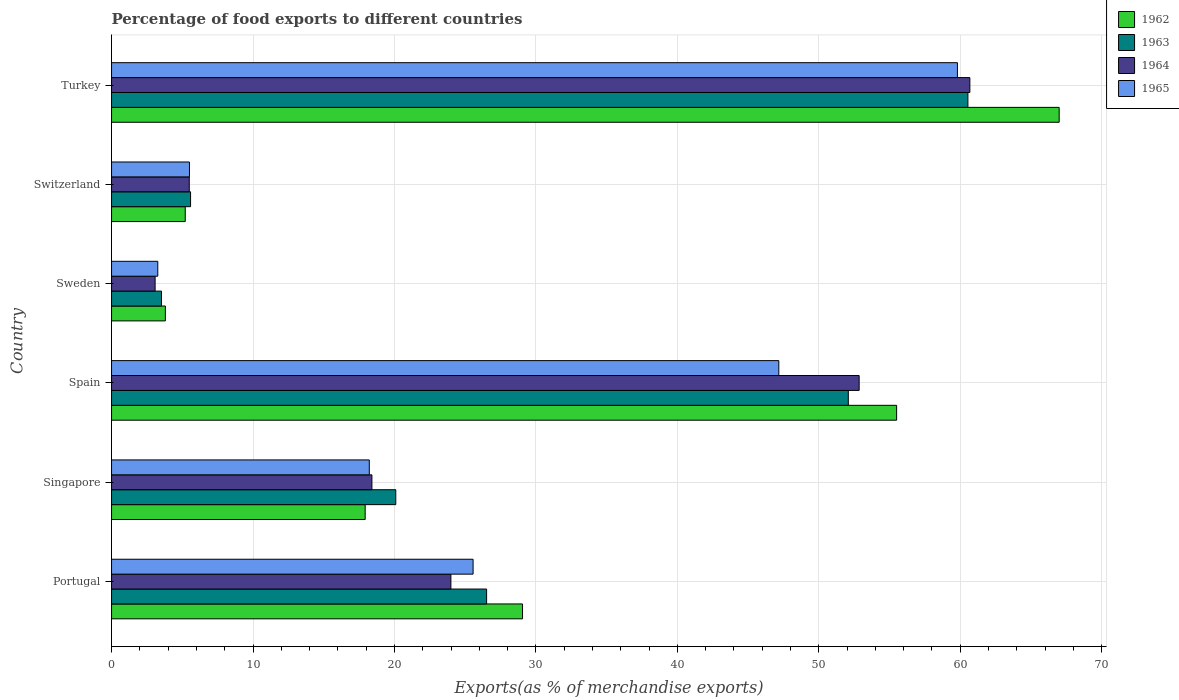How many different coloured bars are there?
Ensure brevity in your answer.  4. Are the number of bars per tick equal to the number of legend labels?
Offer a terse response. Yes. What is the label of the 3rd group of bars from the top?
Offer a terse response. Sweden. What is the percentage of exports to different countries in 1965 in Switzerland?
Provide a short and direct response. 5.51. Across all countries, what is the maximum percentage of exports to different countries in 1963?
Your response must be concise. 60.54. Across all countries, what is the minimum percentage of exports to different countries in 1964?
Make the answer very short. 3.08. In which country was the percentage of exports to different countries in 1965 maximum?
Your answer should be compact. Turkey. What is the total percentage of exports to different countries in 1963 in the graph?
Provide a short and direct response. 168.35. What is the difference between the percentage of exports to different countries in 1964 in Sweden and that in Switzerland?
Your answer should be compact. -2.41. What is the difference between the percentage of exports to different countries in 1963 in Portugal and the percentage of exports to different countries in 1965 in Singapore?
Your answer should be very brief. 8.29. What is the average percentage of exports to different countries in 1963 per country?
Ensure brevity in your answer.  28.06. What is the difference between the percentage of exports to different countries in 1962 and percentage of exports to different countries in 1965 in Singapore?
Ensure brevity in your answer.  -0.29. What is the ratio of the percentage of exports to different countries in 1962 in Portugal to that in Singapore?
Give a very brief answer. 1.62. Is the percentage of exports to different countries in 1963 in Portugal less than that in Switzerland?
Provide a succinct answer. No. What is the difference between the highest and the second highest percentage of exports to different countries in 1964?
Offer a terse response. 7.83. What is the difference between the highest and the lowest percentage of exports to different countries in 1965?
Your answer should be very brief. 56.53. What does the 1st bar from the top in Sweden represents?
Offer a very short reply. 1965. What does the 3rd bar from the bottom in Portugal represents?
Ensure brevity in your answer.  1964. How many bars are there?
Your response must be concise. 24. What is the difference between two consecutive major ticks on the X-axis?
Provide a succinct answer. 10. Are the values on the major ticks of X-axis written in scientific E-notation?
Your answer should be very brief. No. Does the graph contain grids?
Keep it short and to the point. Yes. Where does the legend appear in the graph?
Your answer should be compact. Top right. How many legend labels are there?
Offer a very short reply. 4. How are the legend labels stacked?
Your response must be concise. Vertical. What is the title of the graph?
Offer a very short reply. Percentage of food exports to different countries. What is the label or title of the X-axis?
Provide a short and direct response. Exports(as % of merchandise exports). What is the label or title of the Y-axis?
Your answer should be very brief. Country. What is the Exports(as % of merchandise exports) of 1962 in Portugal?
Make the answer very short. 29.05. What is the Exports(as % of merchandise exports) in 1963 in Portugal?
Keep it short and to the point. 26.51. What is the Exports(as % of merchandise exports) of 1964 in Portugal?
Make the answer very short. 23.99. What is the Exports(as % of merchandise exports) in 1965 in Portugal?
Give a very brief answer. 25.56. What is the Exports(as % of merchandise exports) of 1962 in Singapore?
Provide a succinct answer. 17.93. What is the Exports(as % of merchandise exports) of 1963 in Singapore?
Give a very brief answer. 20.09. What is the Exports(as % of merchandise exports) in 1964 in Singapore?
Keep it short and to the point. 18.41. What is the Exports(as % of merchandise exports) in 1965 in Singapore?
Ensure brevity in your answer.  18.22. What is the Exports(as % of merchandise exports) in 1962 in Spain?
Your answer should be very brief. 55.5. What is the Exports(as % of merchandise exports) in 1963 in Spain?
Your answer should be compact. 52.09. What is the Exports(as % of merchandise exports) of 1964 in Spain?
Ensure brevity in your answer.  52.85. What is the Exports(as % of merchandise exports) of 1965 in Spain?
Ensure brevity in your answer.  47.17. What is the Exports(as % of merchandise exports) of 1962 in Sweden?
Keep it short and to the point. 3.8. What is the Exports(as % of merchandise exports) of 1963 in Sweden?
Keep it short and to the point. 3.53. What is the Exports(as % of merchandise exports) in 1964 in Sweden?
Offer a very short reply. 3.08. What is the Exports(as % of merchandise exports) of 1965 in Sweden?
Your answer should be very brief. 3.27. What is the Exports(as % of merchandise exports) in 1962 in Switzerland?
Provide a succinct answer. 5.21. What is the Exports(as % of merchandise exports) of 1963 in Switzerland?
Provide a succinct answer. 5.59. What is the Exports(as % of merchandise exports) in 1964 in Switzerland?
Your answer should be compact. 5.49. What is the Exports(as % of merchandise exports) of 1965 in Switzerland?
Provide a succinct answer. 5.51. What is the Exports(as % of merchandise exports) of 1962 in Turkey?
Offer a terse response. 66.99. What is the Exports(as % of merchandise exports) in 1963 in Turkey?
Your response must be concise. 60.54. What is the Exports(as % of merchandise exports) in 1964 in Turkey?
Offer a terse response. 60.68. What is the Exports(as % of merchandise exports) in 1965 in Turkey?
Your answer should be very brief. 59.8. Across all countries, what is the maximum Exports(as % of merchandise exports) of 1962?
Keep it short and to the point. 66.99. Across all countries, what is the maximum Exports(as % of merchandise exports) in 1963?
Keep it short and to the point. 60.54. Across all countries, what is the maximum Exports(as % of merchandise exports) of 1964?
Offer a terse response. 60.68. Across all countries, what is the maximum Exports(as % of merchandise exports) in 1965?
Give a very brief answer. 59.8. Across all countries, what is the minimum Exports(as % of merchandise exports) of 1962?
Keep it short and to the point. 3.8. Across all countries, what is the minimum Exports(as % of merchandise exports) in 1963?
Keep it short and to the point. 3.53. Across all countries, what is the minimum Exports(as % of merchandise exports) of 1964?
Keep it short and to the point. 3.08. Across all countries, what is the minimum Exports(as % of merchandise exports) in 1965?
Ensure brevity in your answer.  3.27. What is the total Exports(as % of merchandise exports) of 1962 in the graph?
Offer a terse response. 178.49. What is the total Exports(as % of merchandise exports) of 1963 in the graph?
Offer a terse response. 168.35. What is the total Exports(as % of merchandise exports) in 1964 in the graph?
Give a very brief answer. 164.5. What is the total Exports(as % of merchandise exports) of 1965 in the graph?
Your response must be concise. 159.53. What is the difference between the Exports(as % of merchandise exports) of 1962 in Portugal and that in Singapore?
Offer a very short reply. 11.12. What is the difference between the Exports(as % of merchandise exports) in 1963 in Portugal and that in Singapore?
Your answer should be compact. 6.42. What is the difference between the Exports(as % of merchandise exports) in 1964 in Portugal and that in Singapore?
Your response must be concise. 5.58. What is the difference between the Exports(as % of merchandise exports) of 1965 in Portugal and that in Singapore?
Keep it short and to the point. 7.34. What is the difference between the Exports(as % of merchandise exports) of 1962 in Portugal and that in Spain?
Offer a very short reply. -26.45. What is the difference between the Exports(as % of merchandise exports) in 1963 in Portugal and that in Spain?
Offer a terse response. -25.57. What is the difference between the Exports(as % of merchandise exports) in 1964 in Portugal and that in Spain?
Offer a very short reply. -28.86. What is the difference between the Exports(as % of merchandise exports) in 1965 in Portugal and that in Spain?
Offer a very short reply. -21.61. What is the difference between the Exports(as % of merchandise exports) of 1962 in Portugal and that in Sweden?
Provide a succinct answer. 25.25. What is the difference between the Exports(as % of merchandise exports) of 1963 in Portugal and that in Sweden?
Give a very brief answer. 22.98. What is the difference between the Exports(as % of merchandise exports) of 1964 in Portugal and that in Sweden?
Provide a short and direct response. 20.91. What is the difference between the Exports(as % of merchandise exports) of 1965 in Portugal and that in Sweden?
Your answer should be compact. 22.29. What is the difference between the Exports(as % of merchandise exports) of 1962 in Portugal and that in Switzerland?
Your answer should be compact. 23.85. What is the difference between the Exports(as % of merchandise exports) in 1963 in Portugal and that in Switzerland?
Keep it short and to the point. 20.93. What is the difference between the Exports(as % of merchandise exports) in 1964 in Portugal and that in Switzerland?
Keep it short and to the point. 18.5. What is the difference between the Exports(as % of merchandise exports) of 1965 in Portugal and that in Switzerland?
Your answer should be very brief. 20.05. What is the difference between the Exports(as % of merchandise exports) in 1962 in Portugal and that in Turkey?
Provide a succinct answer. -37.94. What is the difference between the Exports(as % of merchandise exports) in 1963 in Portugal and that in Turkey?
Your response must be concise. -34.03. What is the difference between the Exports(as % of merchandise exports) in 1964 in Portugal and that in Turkey?
Offer a terse response. -36.69. What is the difference between the Exports(as % of merchandise exports) in 1965 in Portugal and that in Turkey?
Your answer should be compact. -34.24. What is the difference between the Exports(as % of merchandise exports) in 1962 in Singapore and that in Spain?
Provide a short and direct response. -37.57. What is the difference between the Exports(as % of merchandise exports) of 1963 in Singapore and that in Spain?
Provide a succinct answer. -31.99. What is the difference between the Exports(as % of merchandise exports) of 1964 in Singapore and that in Spain?
Your response must be concise. -34.45. What is the difference between the Exports(as % of merchandise exports) of 1965 in Singapore and that in Spain?
Provide a succinct answer. -28.95. What is the difference between the Exports(as % of merchandise exports) in 1962 in Singapore and that in Sweden?
Your answer should be compact. 14.13. What is the difference between the Exports(as % of merchandise exports) of 1963 in Singapore and that in Sweden?
Give a very brief answer. 16.56. What is the difference between the Exports(as % of merchandise exports) of 1964 in Singapore and that in Sweden?
Offer a terse response. 15.33. What is the difference between the Exports(as % of merchandise exports) of 1965 in Singapore and that in Sweden?
Keep it short and to the point. 14.95. What is the difference between the Exports(as % of merchandise exports) in 1962 in Singapore and that in Switzerland?
Your response must be concise. 12.72. What is the difference between the Exports(as % of merchandise exports) of 1963 in Singapore and that in Switzerland?
Offer a terse response. 14.51. What is the difference between the Exports(as % of merchandise exports) in 1964 in Singapore and that in Switzerland?
Your answer should be compact. 12.91. What is the difference between the Exports(as % of merchandise exports) of 1965 in Singapore and that in Switzerland?
Your response must be concise. 12.71. What is the difference between the Exports(as % of merchandise exports) of 1962 in Singapore and that in Turkey?
Ensure brevity in your answer.  -49.06. What is the difference between the Exports(as % of merchandise exports) in 1963 in Singapore and that in Turkey?
Your response must be concise. -40.45. What is the difference between the Exports(as % of merchandise exports) in 1964 in Singapore and that in Turkey?
Your answer should be very brief. -42.27. What is the difference between the Exports(as % of merchandise exports) in 1965 in Singapore and that in Turkey?
Provide a succinct answer. -41.58. What is the difference between the Exports(as % of merchandise exports) in 1962 in Spain and that in Sweden?
Give a very brief answer. 51.7. What is the difference between the Exports(as % of merchandise exports) in 1963 in Spain and that in Sweden?
Your answer should be compact. 48.56. What is the difference between the Exports(as % of merchandise exports) in 1964 in Spain and that in Sweden?
Give a very brief answer. 49.77. What is the difference between the Exports(as % of merchandise exports) in 1965 in Spain and that in Sweden?
Provide a short and direct response. 43.9. What is the difference between the Exports(as % of merchandise exports) of 1962 in Spain and that in Switzerland?
Your response must be concise. 50.29. What is the difference between the Exports(as % of merchandise exports) of 1963 in Spain and that in Switzerland?
Offer a very short reply. 46.5. What is the difference between the Exports(as % of merchandise exports) in 1964 in Spain and that in Switzerland?
Give a very brief answer. 47.36. What is the difference between the Exports(as % of merchandise exports) of 1965 in Spain and that in Switzerland?
Provide a succinct answer. 41.67. What is the difference between the Exports(as % of merchandise exports) in 1962 in Spain and that in Turkey?
Provide a short and direct response. -11.49. What is the difference between the Exports(as % of merchandise exports) of 1963 in Spain and that in Turkey?
Provide a succinct answer. -8.46. What is the difference between the Exports(as % of merchandise exports) of 1964 in Spain and that in Turkey?
Give a very brief answer. -7.83. What is the difference between the Exports(as % of merchandise exports) of 1965 in Spain and that in Turkey?
Your answer should be very brief. -12.63. What is the difference between the Exports(as % of merchandise exports) of 1962 in Sweden and that in Switzerland?
Your answer should be very brief. -1.4. What is the difference between the Exports(as % of merchandise exports) of 1963 in Sweden and that in Switzerland?
Offer a very short reply. -2.06. What is the difference between the Exports(as % of merchandise exports) of 1964 in Sweden and that in Switzerland?
Offer a very short reply. -2.41. What is the difference between the Exports(as % of merchandise exports) in 1965 in Sweden and that in Switzerland?
Your response must be concise. -2.24. What is the difference between the Exports(as % of merchandise exports) in 1962 in Sweden and that in Turkey?
Your answer should be compact. -63.19. What is the difference between the Exports(as % of merchandise exports) of 1963 in Sweden and that in Turkey?
Offer a very short reply. -57.01. What is the difference between the Exports(as % of merchandise exports) in 1964 in Sweden and that in Turkey?
Your answer should be very brief. -57.6. What is the difference between the Exports(as % of merchandise exports) of 1965 in Sweden and that in Turkey?
Offer a very short reply. -56.53. What is the difference between the Exports(as % of merchandise exports) of 1962 in Switzerland and that in Turkey?
Your answer should be very brief. -61.78. What is the difference between the Exports(as % of merchandise exports) in 1963 in Switzerland and that in Turkey?
Give a very brief answer. -54.96. What is the difference between the Exports(as % of merchandise exports) of 1964 in Switzerland and that in Turkey?
Your answer should be very brief. -55.18. What is the difference between the Exports(as % of merchandise exports) of 1965 in Switzerland and that in Turkey?
Offer a very short reply. -54.29. What is the difference between the Exports(as % of merchandise exports) in 1962 in Portugal and the Exports(as % of merchandise exports) in 1963 in Singapore?
Ensure brevity in your answer.  8.96. What is the difference between the Exports(as % of merchandise exports) in 1962 in Portugal and the Exports(as % of merchandise exports) in 1964 in Singapore?
Make the answer very short. 10.65. What is the difference between the Exports(as % of merchandise exports) of 1962 in Portugal and the Exports(as % of merchandise exports) of 1965 in Singapore?
Provide a succinct answer. 10.83. What is the difference between the Exports(as % of merchandise exports) in 1963 in Portugal and the Exports(as % of merchandise exports) in 1964 in Singapore?
Give a very brief answer. 8.11. What is the difference between the Exports(as % of merchandise exports) of 1963 in Portugal and the Exports(as % of merchandise exports) of 1965 in Singapore?
Offer a very short reply. 8.29. What is the difference between the Exports(as % of merchandise exports) in 1964 in Portugal and the Exports(as % of merchandise exports) in 1965 in Singapore?
Give a very brief answer. 5.77. What is the difference between the Exports(as % of merchandise exports) in 1962 in Portugal and the Exports(as % of merchandise exports) in 1963 in Spain?
Your answer should be very brief. -23.03. What is the difference between the Exports(as % of merchandise exports) in 1962 in Portugal and the Exports(as % of merchandise exports) in 1964 in Spain?
Make the answer very short. -23.8. What is the difference between the Exports(as % of merchandise exports) in 1962 in Portugal and the Exports(as % of merchandise exports) in 1965 in Spain?
Provide a short and direct response. -18.12. What is the difference between the Exports(as % of merchandise exports) of 1963 in Portugal and the Exports(as % of merchandise exports) of 1964 in Spain?
Give a very brief answer. -26.34. What is the difference between the Exports(as % of merchandise exports) of 1963 in Portugal and the Exports(as % of merchandise exports) of 1965 in Spain?
Your answer should be very brief. -20.66. What is the difference between the Exports(as % of merchandise exports) of 1964 in Portugal and the Exports(as % of merchandise exports) of 1965 in Spain?
Your answer should be very brief. -23.18. What is the difference between the Exports(as % of merchandise exports) of 1962 in Portugal and the Exports(as % of merchandise exports) of 1963 in Sweden?
Your answer should be compact. 25.53. What is the difference between the Exports(as % of merchandise exports) of 1962 in Portugal and the Exports(as % of merchandise exports) of 1964 in Sweden?
Ensure brevity in your answer.  25.98. What is the difference between the Exports(as % of merchandise exports) in 1962 in Portugal and the Exports(as % of merchandise exports) in 1965 in Sweden?
Ensure brevity in your answer.  25.79. What is the difference between the Exports(as % of merchandise exports) of 1963 in Portugal and the Exports(as % of merchandise exports) of 1964 in Sweden?
Keep it short and to the point. 23.44. What is the difference between the Exports(as % of merchandise exports) in 1963 in Portugal and the Exports(as % of merchandise exports) in 1965 in Sweden?
Give a very brief answer. 23.25. What is the difference between the Exports(as % of merchandise exports) in 1964 in Portugal and the Exports(as % of merchandise exports) in 1965 in Sweden?
Provide a succinct answer. 20.72. What is the difference between the Exports(as % of merchandise exports) in 1962 in Portugal and the Exports(as % of merchandise exports) in 1963 in Switzerland?
Offer a very short reply. 23.47. What is the difference between the Exports(as % of merchandise exports) in 1962 in Portugal and the Exports(as % of merchandise exports) in 1964 in Switzerland?
Offer a terse response. 23.56. What is the difference between the Exports(as % of merchandise exports) of 1962 in Portugal and the Exports(as % of merchandise exports) of 1965 in Switzerland?
Ensure brevity in your answer.  23.55. What is the difference between the Exports(as % of merchandise exports) of 1963 in Portugal and the Exports(as % of merchandise exports) of 1964 in Switzerland?
Ensure brevity in your answer.  21.02. What is the difference between the Exports(as % of merchandise exports) in 1963 in Portugal and the Exports(as % of merchandise exports) in 1965 in Switzerland?
Offer a terse response. 21.01. What is the difference between the Exports(as % of merchandise exports) in 1964 in Portugal and the Exports(as % of merchandise exports) in 1965 in Switzerland?
Make the answer very short. 18.48. What is the difference between the Exports(as % of merchandise exports) in 1962 in Portugal and the Exports(as % of merchandise exports) in 1963 in Turkey?
Ensure brevity in your answer.  -31.49. What is the difference between the Exports(as % of merchandise exports) of 1962 in Portugal and the Exports(as % of merchandise exports) of 1964 in Turkey?
Provide a succinct answer. -31.62. What is the difference between the Exports(as % of merchandise exports) in 1962 in Portugal and the Exports(as % of merchandise exports) in 1965 in Turkey?
Your answer should be very brief. -30.74. What is the difference between the Exports(as % of merchandise exports) in 1963 in Portugal and the Exports(as % of merchandise exports) in 1964 in Turkey?
Your response must be concise. -34.16. What is the difference between the Exports(as % of merchandise exports) in 1963 in Portugal and the Exports(as % of merchandise exports) in 1965 in Turkey?
Keep it short and to the point. -33.28. What is the difference between the Exports(as % of merchandise exports) of 1964 in Portugal and the Exports(as % of merchandise exports) of 1965 in Turkey?
Provide a short and direct response. -35.81. What is the difference between the Exports(as % of merchandise exports) in 1962 in Singapore and the Exports(as % of merchandise exports) in 1963 in Spain?
Offer a terse response. -34.16. What is the difference between the Exports(as % of merchandise exports) in 1962 in Singapore and the Exports(as % of merchandise exports) in 1964 in Spain?
Keep it short and to the point. -34.92. What is the difference between the Exports(as % of merchandise exports) of 1962 in Singapore and the Exports(as % of merchandise exports) of 1965 in Spain?
Offer a very short reply. -29.24. What is the difference between the Exports(as % of merchandise exports) of 1963 in Singapore and the Exports(as % of merchandise exports) of 1964 in Spain?
Provide a short and direct response. -32.76. What is the difference between the Exports(as % of merchandise exports) in 1963 in Singapore and the Exports(as % of merchandise exports) in 1965 in Spain?
Offer a terse response. -27.08. What is the difference between the Exports(as % of merchandise exports) of 1964 in Singapore and the Exports(as % of merchandise exports) of 1965 in Spain?
Keep it short and to the point. -28.77. What is the difference between the Exports(as % of merchandise exports) of 1962 in Singapore and the Exports(as % of merchandise exports) of 1963 in Sweden?
Your answer should be very brief. 14.4. What is the difference between the Exports(as % of merchandise exports) in 1962 in Singapore and the Exports(as % of merchandise exports) in 1964 in Sweden?
Keep it short and to the point. 14.85. What is the difference between the Exports(as % of merchandise exports) in 1962 in Singapore and the Exports(as % of merchandise exports) in 1965 in Sweden?
Your answer should be very brief. 14.66. What is the difference between the Exports(as % of merchandise exports) of 1963 in Singapore and the Exports(as % of merchandise exports) of 1964 in Sweden?
Offer a very short reply. 17.01. What is the difference between the Exports(as % of merchandise exports) of 1963 in Singapore and the Exports(as % of merchandise exports) of 1965 in Sweden?
Provide a succinct answer. 16.83. What is the difference between the Exports(as % of merchandise exports) of 1964 in Singapore and the Exports(as % of merchandise exports) of 1965 in Sweden?
Offer a very short reply. 15.14. What is the difference between the Exports(as % of merchandise exports) in 1962 in Singapore and the Exports(as % of merchandise exports) in 1963 in Switzerland?
Ensure brevity in your answer.  12.34. What is the difference between the Exports(as % of merchandise exports) of 1962 in Singapore and the Exports(as % of merchandise exports) of 1964 in Switzerland?
Offer a very short reply. 12.44. What is the difference between the Exports(as % of merchandise exports) of 1962 in Singapore and the Exports(as % of merchandise exports) of 1965 in Switzerland?
Provide a succinct answer. 12.42. What is the difference between the Exports(as % of merchandise exports) in 1963 in Singapore and the Exports(as % of merchandise exports) in 1964 in Switzerland?
Keep it short and to the point. 14.6. What is the difference between the Exports(as % of merchandise exports) of 1963 in Singapore and the Exports(as % of merchandise exports) of 1965 in Switzerland?
Ensure brevity in your answer.  14.59. What is the difference between the Exports(as % of merchandise exports) in 1964 in Singapore and the Exports(as % of merchandise exports) in 1965 in Switzerland?
Offer a very short reply. 12.9. What is the difference between the Exports(as % of merchandise exports) in 1962 in Singapore and the Exports(as % of merchandise exports) in 1963 in Turkey?
Make the answer very short. -42.61. What is the difference between the Exports(as % of merchandise exports) of 1962 in Singapore and the Exports(as % of merchandise exports) of 1964 in Turkey?
Your answer should be very brief. -42.75. What is the difference between the Exports(as % of merchandise exports) in 1962 in Singapore and the Exports(as % of merchandise exports) in 1965 in Turkey?
Your answer should be compact. -41.87. What is the difference between the Exports(as % of merchandise exports) in 1963 in Singapore and the Exports(as % of merchandise exports) in 1964 in Turkey?
Offer a terse response. -40.59. What is the difference between the Exports(as % of merchandise exports) of 1963 in Singapore and the Exports(as % of merchandise exports) of 1965 in Turkey?
Provide a short and direct response. -39.71. What is the difference between the Exports(as % of merchandise exports) of 1964 in Singapore and the Exports(as % of merchandise exports) of 1965 in Turkey?
Offer a very short reply. -41.39. What is the difference between the Exports(as % of merchandise exports) of 1962 in Spain and the Exports(as % of merchandise exports) of 1963 in Sweden?
Your answer should be compact. 51.97. What is the difference between the Exports(as % of merchandise exports) in 1962 in Spain and the Exports(as % of merchandise exports) in 1964 in Sweden?
Your answer should be compact. 52.42. What is the difference between the Exports(as % of merchandise exports) in 1962 in Spain and the Exports(as % of merchandise exports) in 1965 in Sweden?
Provide a short and direct response. 52.23. What is the difference between the Exports(as % of merchandise exports) in 1963 in Spain and the Exports(as % of merchandise exports) in 1964 in Sweden?
Ensure brevity in your answer.  49.01. What is the difference between the Exports(as % of merchandise exports) of 1963 in Spain and the Exports(as % of merchandise exports) of 1965 in Sweden?
Your response must be concise. 48.82. What is the difference between the Exports(as % of merchandise exports) in 1964 in Spain and the Exports(as % of merchandise exports) in 1965 in Sweden?
Provide a succinct answer. 49.58. What is the difference between the Exports(as % of merchandise exports) in 1962 in Spain and the Exports(as % of merchandise exports) in 1963 in Switzerland?
Make the answer very short. 49.92. What is the difference between the Exports(as % of merchandise exports) of 1962 in Spain and the Exports(as % of merchandise exports) of 1964 in Switzerland?
Offer a very short reply. 50.01. What is the difference between the Exports(as % of merchandise exports) in 1962 in Spain and the Exports(as % of merchandise exports) in 1965 in Switzerland?
Your answer should be compact. 49.99. What is the difference between the Exports(as % of merchandise exports) of 1963 in Spain and the Exports(as % of merchandise exports) of 1964 in Switzerland?
Your answer should be compact. 46.59. What is the difference between the Exports(as % of merchandise exports) in 1963 in Spain and the Exports(as % of merchandise exports) in 1965 in Switzerland?
Make the answer very short. 46.58. What is the difference between the Exports(as % of merchandise exports) in 1964 in Spain and the Exports(as % of merchandise exports) in 1965 in Switzerland?
Provide a short and direct response. 47.35. What is the difference between the Exports(as % of merchandise exports) in 1962 in Spain and the Exports(as % of merchandise exports) in 1963 in Turkey?
Keep it short and to the point. -5.04. What is the difference between the Exports(as % of merchandise exports) in 1962 in Spain and the Exports(as % of merchandise exports) in 1964 in Turkey?
Your answer should be compact. -5.18. What is the difference between the Exports(as % of merchandise exports) in 1962 in Spain and the Exports(as % of merchandise exports) in 1965 in Turkey?
Ensure brevity in your answer.  -4.3. What is the difference between the Exports(as % of merchandise exports) of 1963 in Spain and the Exports(as % of merchandise exports) of 1964 in Turkey?
Your response must be concise. -8.59. What is the difference between the Exports(as % of merchandise exports) of 1963 in Spain and the Exports(as % of merchandise exports) of 1965 in Turkey?
Ensure brevity in your answer.  -7.71. What is the difference between the Exports(as % of merchandise exports) of 1964 in Spain and the Exports(as % of merchandise exports) of 1965 in Turkey?
Make the answer very short. -6.95. What is the difference between the Exports(as % of merchandise exports) in 1962 in Sweden and the Exports(as % of merchandise exports) in 1963 in Switzerland?
Ensure brevity in your answer.  -1.78. What is the difference between the Exports(as % of merchandise exports) of 1962 in Sweden and the Exports(as % of merchandise exports) of 1964 in Switzerland?
Offer a terse response. -1.69. What is the difference between the Exports(as % of merchandise exports) in 1962 in Sweden and the Exports(as % of merchandise exports) in 1965 in Switzerland?
Your response must be concise. -1.7. What is the difference between the Exports(as % of merchandise exports) in 1963 in Sweden and the Exports(as % of merchandise exports) in 1964 in Switzerland?
Keep it short and to the point. -1.96. What is the difference between the Exports(as % of merchandise exports) in 1963 in Sweden and the Exports(as % of merchandise exports) in 1965 in Switzerland?
Your answer should be compact. -1.98. What is the difference between the Exports(as % of merchandise exports) in 1964 in Sweden and the Exports(as % of merchandise exports) in 1965 in Switzerland?
Give a very brief answer. -2.43. What is the difference between the Exports(as % of merchandise exports) in 1962 in Sweden and the Exports(as % of merchandise exports) in 1963 in Turkey?
Ensure brevity in your answer.  -56.74. What is the difference between the Exports(as % of merchandise exports) in 1962 in Sweden and the Exports(as % of merchandise exports) in 1964 in Turkey?
Your response must be concise. -56.87. What is the difference between the Exports(as % of merchandise exports) in 1962 in Sweden and the Exports(as % of merchandise exports) in 1965 in Turkey?
Offer a very short reply. -55.99. What is the difference between the Exports(as % of merchandise exports) in 1963 in Sweden and the Exports(as % of merchandise exports) in 1964 in Turkey?
Provide a short and direct response. -57.15. What is the difference between the Exports(as % of merchandise exports) of 1963 in Sweden and the Exports(as % of merchandise exports) of 1965 in Turkey?
Your response must be concise. -56.27. What is the difference between the Exports(as % of merchandise exports) in 1964 in Sweden and the Exports(as % of merchandise exports) in 1965 in Turkey?
Give a very brief answer. -56.72. What is the difference between the Exports(as % of merchandise exports) in 1962 in Switzerland and the Exports(as % of merchandise exports) in 1963 in Turkey?
Provide a succinct answer. -55.33. What is the difference between the Exports(as % of merchandise exports) in 1962 in Switzerland and the Exports(as % of merchandise exports) in 1964 in Turkey?
Your answer should be very brief. -55.47. What is the difference between the Exports(as % of merchandise exports) of 1962 in Switzerland and the Exports(as % of merchandise exports) of 1965 in Turkey?
Offer a terse response. -54.59. What is the difference between the Exports(as % of merchandise exports) in 1963 in Switzerland and the Exports(as % of merchandise exports) in 1964 in Turkey?
Ensure brevity in your answer.  -55.09. What is the difference between the Exports(as % of merchandise exports) in 1963 in Switzerland and the Exports(as % of merchandise exports) in 1965 in Turkey?
Offer a very short reply. -54.21. What is the difference between the Exports(as % of merchandise exports) of 1964 in Switzerland and the Exports(as % of merchandise exports) of 1965 in Turkey?
Your answer should be compact. -54.31. What is the average Exports(as % of merchandise exports) of 1962 per country?
Provide a short and direct response. 29.75. What is the average Exports(as % of merchandise exports) of 1963 per country?
Make the answer very short. 28.06. What is the average Exports(as % of merchandise exports) of 1964 per country?
Make the answer very short. 27.42. What is the average Exports(as % of merchandise exports) of 1965 per country?
Your response must be concise. 26.59. What is the difference between the Exports(as % of merchandise exports) of 1962 and Exports(as % of merchandise exports) of 1963 in Portugal?
Give a very brief answer. 2.54. What is the difference between the Exports(as % of merchandise exports) of 1962 and Exports(as % of merchandise exports) of 1964 in Portugal?
Provide a succinct answer. 5.06. What is the difference between the Exports(as % of merchandise exports) in 1962 and Exports(as % of merchandise exports) in 1965 in Portugal?
Your answer should be very brief. 3.49. What is the difference between the Exports(as % of merchandise exports) in 1963 and Exports(as % of merchandise exports) in 1964 in Portugal?
Keep it short and to the point. 2.52. What is the difference between the Exports(as % of merchandise exports) in 1963 and Exports(as % of merchandise exports) in 1965 in Portugal?
Make the answer very short. 0.95. What is the difference between the Exports(as % of merchandise exports) of 1964 and Exports(as % of merchandise exports) of 1965 in Portugal?
Your answer should be very brief. -1.57. What is the difference between the Exports(as % of merchandise exports) in 1962 and Exports(as % of merchandise exports) in 1963 in Singapore?
Provide a short and direct response. -2.16. What is the difference between the Exports(as % of merchandise exports) in 1962 and Exports(as % of merchandise exports) in 1964 in Singapore?
Ensure brevity in your answer.  -0.48. What is the difference between the Exports(as % of merchandise exports) in 1962 and Exports(as % of merchandise exports) in 1965 in Singapore?
Provide a short and direct response. -0.29. What is the difference between the Exports(as % of merchandise exports) of 1963 and Exports(as % of merchandise exports) of 1964 in Singapore?
Give a very brief answer. 1.69. What is the difference between the Exports(as % of merchandise exports) in 1963 and Exports(as % of merchandise exports) in 1965 in Singapore?
Your answer should be compact. 1.87. What is the difference between the Exports(as % of merchandise exports) in 1964 and Exports(as % of merchandise exports) in 1965 in Singapore?
Make the answer very short. 0.18. What is the difference between the Exports(as % of merchandise exports) in 1962 and Exports(as % of merchandise exports) in 1963 in Spain?
Offer a very short reply. 3.42. What is the difference between the Exports(as % of merchandise exports) in 1962 and Exports(as % of merchandise exports) in 1964 in Spain?
Your answer should be very brief. 2.65. What is the difference between the Exports(as % of merchandise exports) in 1962 and Exports(as % of merchandise exports) in 1965 in Spain?
Your answer should be compact. 8.33. What is the difference between the Exports(as % of merchandise exports) in 1963 and Exports(as % of merchandise exports) in 1964 in Spain?
Offer a very short reply. -0.77. What is the difference between the Exports(as % of merchandise exports) in 1963 and Exports(as % of merchandise exports) in 1965 in Spain?
Keep it short and to the point. 4.91. What is the difference between the Exports(as % of merchandise exports) in 1964 and Exports(as % of merchandise exports) in 1965 in Spain?
Provide a succinct answer. 5.68. What is the difference between the Exports(as % of merchandise exports) in 1962 and Exports(as % of merchandise exports) in 1963 in Sweden?
Give a very brief answer. 0.28. What is the difference between the Exports(as % of merchandise exports) in 1962 and Exports(as % of merchandise exports) in 1964 in Sweden?
Provide a succinct answer. 0.73. What is the difference between the Exports(as % of merchandise exports) in 1962 and Exports(as % of merchandise exports) in 1965 in Sweden?
Make the answer very short. 0.54. What is the difference between the Exports(as % of merchandise exports) of 1963 and Exports(as % of merchandise exports) of 1964 in Sweden?
Your answer should be very brief. 0.45. What is the difference between the Exports(as % of merchandise exports) in 1963 and Exports(as % of merchandise exports) in 1965 in Sweden?
Provide a succinct answer. 0.26. What is the difference between the Exports(as % of merchandise exports) of 1964 and Exports(as % of merchandise exports) of 1965 in Sweden?
Give a very brief answer. -0.19. What is the difference between the Exports(as % of merchandise exports) of 1962 and Exports(as % of merchandise exports) of 1963 in Switzerland?
Your answer should be very brief. -0.38. What is the difference between the Exports(as % of merchandise exports) of 1962 and Exports(as % of merchandise exports) of 1964 in Switzerland?
Your response must be concise. -0.28. What is the difference between the Exports(as % of merchandise exports) of 1962 and Exports(as % of merchandise exports) of 1965 in Switzerland?
Provide a succinct answer. -0.3. What is the difference between the Exports(as % of merchandise exports) in 1963 and Exports(as % of merchandise exports) in 1964 in Switzerland?
Your response must be concise. 0.09. What is the difference between the Exports(as % of merchandise exports) of 1963 and Exports(as % of merchandise exports) of 1965 in Switzerland?
Your answer should be compact. 0.08. What is the difference between the Exports(as % of merchandise exports) in 1964 and Exports(as % of merchandise exports) in 1965 in Switzerland?
Offer a terse response. -0.01. What is the difference between the Exports(as % of merchandise exports) of 1962 and Exports(as % of merchandise exports) of 1963 in Turkey?
Offer a terse response. 6.45. What is the difference between the Exports(as % of merchandise exports) of 1962 and Exports(as % of merchandise exports) of 1964 in Turkey?
Offer a terse response. 6.31. What is the difference between the Exports(as % of merchandise exports) in 1962 and Exports(as % of merchandise exports) in 1965 in Turkey?
Ensure brevity in your answer.  7.19. What is the difference between the Exports(as % of merchandise exports) of 1963 and Exports(as % of merchandise exports) of 1964 in Turkey?
Ensure brevity in your answer.  -0.14. What is the difference between the Exports(as % of merchandise exports) of 1963 and Exports(as % of merchandise exports) of 1965 in Turkey?
Make the answer very short. 0.74. What is the difference between the Exports(as % of merchandise exports) in 1964 and Exports(as % of merchandise exports) in 1965 in Turkey?
Make the answer very short. 0.88. What is the ratio of the Exports(as % of merchandise exports) of 1962 in Portugal to that in Singapore?
Make the answer very short. 1.62. What is the ratio of the Exports(as % of merchandise exports) in 1963 in Portugal to that in Singapore?
Give a very brief answer. 1.32. What is the ratio of the Exports(as % of merchandise exports) in 1964 in Portugal to that in Singapore?
Keep it short and to the point. 1.3. What is the ratio of the Exports(as % of merchandise exports) in 1965 in Portugal to that in Singapore?
Provide a short and direct response. 1.4. What is the ratio of the Exports(as % of merchandise exports) of 1962 in Portugal to that in Spain?
Your answer should be compact. 0.52. What is the ratio of the Exports(as % of merchandise exports) in 1963 in Portugal to that in Spain?
Make the answer very short. 0.51. What is the ratio of the Exports(as % of merchandise exports) of 1964 in Portugal to that in Spain?
Your answer should be compact. 0.45. What is the ratio of the Exports(as % of merchandise exports) of 1965 in Portugal to that in Spain?
Provide a short and direct response. 0.54. What is the ratio of the Exports(as % of merchandise exports) in 1962 in Portugal to that in Sweden?
Your answer should be compact. 7.64. What is the ratio of the Exports(as % of merchandise exports) of 1963 in Portugal to that in Sweden?
Offer a very short reply. 7.51. What is the ratio of the Exports(as % of merchandise exports) of 1964 in Portugal to that in Sweden?
Your response must be concise. 7.79. What is the ratio of the Exports(as % of merchandise exports) of 1965 in Portugal to that in Sweden?
Provide a succinct answer. 7.82. What is the ratio of the Exports(as % of merchandise exports) of 1962 in Portugal to that in Switzerland?
Provide a short and direct response. 5.58. What is the ratio of the Exports(as % of merchandise exports) in 1963 in Portugal to that in Switzerland?
Your response must be concise. 4.75. What is the ratio of the Exports(as % of merchandise exports) in 1964 in Portugal to that in Switzerland?
Your answer should be compact. 4.37. What is the ratio of the Exports(as % of merchandise exports) in 1965 in Portugal to that in Switzerland?
Make the answer very short. 4.64. What is the ratio of the Exports(as % of merchandise exports) in 1962 in Portugal to that in Turkey?
Your answer should be compact. 0.43. What is the ratio of the Exports(as % of merchandise exports) of 1963 in Portugal to that in Turkey?
Ensure brevity in your answer.  0.44. What is the ratio of the Exports(as % of merchandise exports) in 1964 in Portugal to that in Turkey?
Offer a terse response. 0.4. What is the ratio of the Exports(as % of merchandise exports) of 1965 in Portugal to that in Turkey?
Your answer should be very brief. 0.43. What is the ratio of the Exports(as % of merchandise exports) of 1962 in Singapore to that in Spain?
Provide a succinct answer. 0.32. What is the ratio of the Exports(as % of merchandise exports) of 1963 in Singapore to that in Spain?
Make the answer very short. 0.39. What is the ratio of the Exports(as % of merchandise exports) in 1964 in Singapore to that in Spain?
Provide a short and direct response. 0.35. What is the ratio of the Exports(as % of merchandise exports) of 1965 in Singapore to that in Spain?
Your answer should be very brief. 0.39. What is the ratio of the Exports(as % of merchandise exports) of 1962 in Singapore to that in Sweden?
Make the answer very short. 4.71. What is the ratio of the Exports(as % of merchandise exports) of 1963 in Singapore to that in Sweden?
Make the answer very short. 5.69. What is the ratio of the Exports(as % of merchandise exports) of 1964 in Singapore to that in Sweden?
Provide a short and direct response. 5.98. What is the ratio of the Exports(as % of merchandise exports) in 1965 in Singapore to that in Sweden?
Provide a succinct answer. 5.58. What is the ratio of the Exports(as % of merchandise exports) in 1962 in Singapore to that in Switzerland?
Provide a succinct answer. 3.44. What is the ratio of the Exports(as % of merchandise exports) in 1963 in Singapore to that in Switzerland?
Keep it short and to the point. 3.6. What is the ratio of the Exports(as % of merchandise exports) in 1964 in Singapore to that in Switzerland?
Provide a short and direct response. 3.35. What is the ratio of the Exports(as % of merchandise exports) of 1965 in Singapore to that in Switzerland?
Provide a short and direct response. 3.31. What is the ratio of the Exports(as % of merchandise exports) of 1962 in Singapore to that in Turkey?
Provide a short and direct response. 0.27. What is the ratio of the Exports(as % of merchandise exports) of 1963 in Singapore to that in Turkey?
Provide a succinct answer. 0.33. What is the ratio of the Exports(as % of merchandise exports) in 1964 in Singapore to that in Turkey?
Make the answer very short. 0.3. What is the ratio of the Exports(as % of merchandise exports) of 1965 in Singapore to that in Turkey?
Make the answer very short. 0.3. What is the ratio of the Exports(as % of merchandise exports) in 1962 in Spain to that in Sweden?
Keep it short and to the point. 14.59. What is the ratio of the Exports(as % of merchandise exports) in 1963 in Spain to that in Sweden?
Your answer should be very brief. 14.76. What is the ratio of the Exports(as % of merchandise exports) in 1964 in Spain to that in Sweden?
Ensure brevity in your answer.  17.17. What is the ratio of the Exports(as % of merchandise exports) in 1965 in Spain to that in Sweden?
Your answer should be very brief. 14.44. What is the ratio of the Exports(as % of merchandise exports) of 1962 in Spain to that in Switzerland?
Provide a short and direct response. 10.65. What is the ratio of the Exports(as % of merchandise exports) of 1963 in Spain to that in Switzerland?
Your response must be concise. 9.33. What is the ratio of the Exports(as % of merchandise exports) of 1964 in Spain to that in Switzerland?
Your answer should be very brief. 9.62. What is the ratio of the Exports(as % of merchandise exports) of 1965 in Spain to that in Switzerland?
Your response must be concise. 8.57. What is the ratio of the Exports(as % of merchandise exports) of 1962 in Spain to that in Turkey?
Keep it short and to the point. 0.83. What is the ratio of the Exports(as % of merchandise exports) in 1963 in Spain to that in Turkey?
Keep it short and to the point. 0.86. What is the ratio of the Exports(as % of merchandise exports) of 1964 in Spain to that in Turkey?
Keep it short and to the point. 0.87. What is the ratio of the Exports(as % of merchandise exports) of 1965 in Spain to that in Turkey?
Provide a short and direct response. 0.79. What is the ratio of the Exports(as % of merchandise exports) of 1962 in Sweden to that in Switzerland?
Provide a short and direct response. 0.73. What is the ratio of the Exports(as % of merchandise exports) of 1963 in Sweden to that in Switzerland?
Ensure brevity in your answer.  0.63. What is the ratio of the Exports(as % of merchandise exports) in 1964 in Sweden to that in Switzerland?
Your response must be concise. 0.56. What is the ratio of the Exports(as % of merchandise exports) in 1965 in Sweden to that in Switzerland?
Provide a short and direct response. 0.59. What is the ratio of the Exports(as % of merchandise exports) of 1962 in Sweden to that in Turkey?
Your answer should be very brief. 0.06. What is the ratio of the Exports(as % of merchandise exports) in 1963 in Sweden to that in Turkey?
Offer a terse response. 0.06. What is the ratio of the Exports(as % of merchandise exports) of 1964 in Sweden to that in Turkey?
Provide a succinct answer. 0.05. What is the ratio of the Exports(as % of merchandise exports) of 1965 in Sweden to that in Turkey?
Your answer should be very brief. 0.05. What is the ratio of the Exports(as % of merchandise exports) of 1962 in Switzerland to that in Turkey?
Your response must be concise. 0.08. What is the ratio of the Exports(as % of merchandise exports) in 1963 in Switzerland to that in Turkey?
Keep it short and to the point. 0.09. What is the ratio of the Exports(as % of merchandise exports) of 1964 in Switzerland to that in Turkey?
Keep it short and to the point. 0.09. What is the ratio of the Exports(as % of merchandise exports) in 1965 in Switzerland to that in Turkey?
Your answer should be very brief. 0.09. What is the difference between the highest and the second highest Exports(as % of merchandise exports) of 1962?
Ensure brevity in your answer.  11.49. What is the difference between the highest and the second highest Exports(as % of merchandise exports) of 1963?
Give a very brief answer. 8.46. What is the difference between the highest and the second highest Exports(as % of merchandise exports) in 1964?
Your answer should be compact. 7.83. What is the difference between the highest and the second highest Exports(as % of merchandise exports) of 1965?
Your answer should be very brief. 12.63. What is the difference between the highest and the lowest Exports(as % of merchandise exports) of 1962?
Your response must be concise. 63.19. What is the difference between the highest and the lowest Exports(as % of merchandise exports) of 1963?
Provide a succinct answer. 57.01. What is the difference between the highest and the lowest Exports(as % of merchandise exports) of 1964?
Keep it short and to the point. 57.6. What is the difference between the highest and the lowest Exports(as % of merchandise exports) in 1965?
Ensure brevity in your answer.  56.53. 